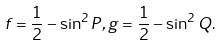<formula> <loc_0><loc_0><loc_500><loc_500>f = \frac { 1 } { 2 } - \sin ^ { 2 } P , g = \frac { 1 } { 2 } - \sin ^ { 2 } Q .</formula> 